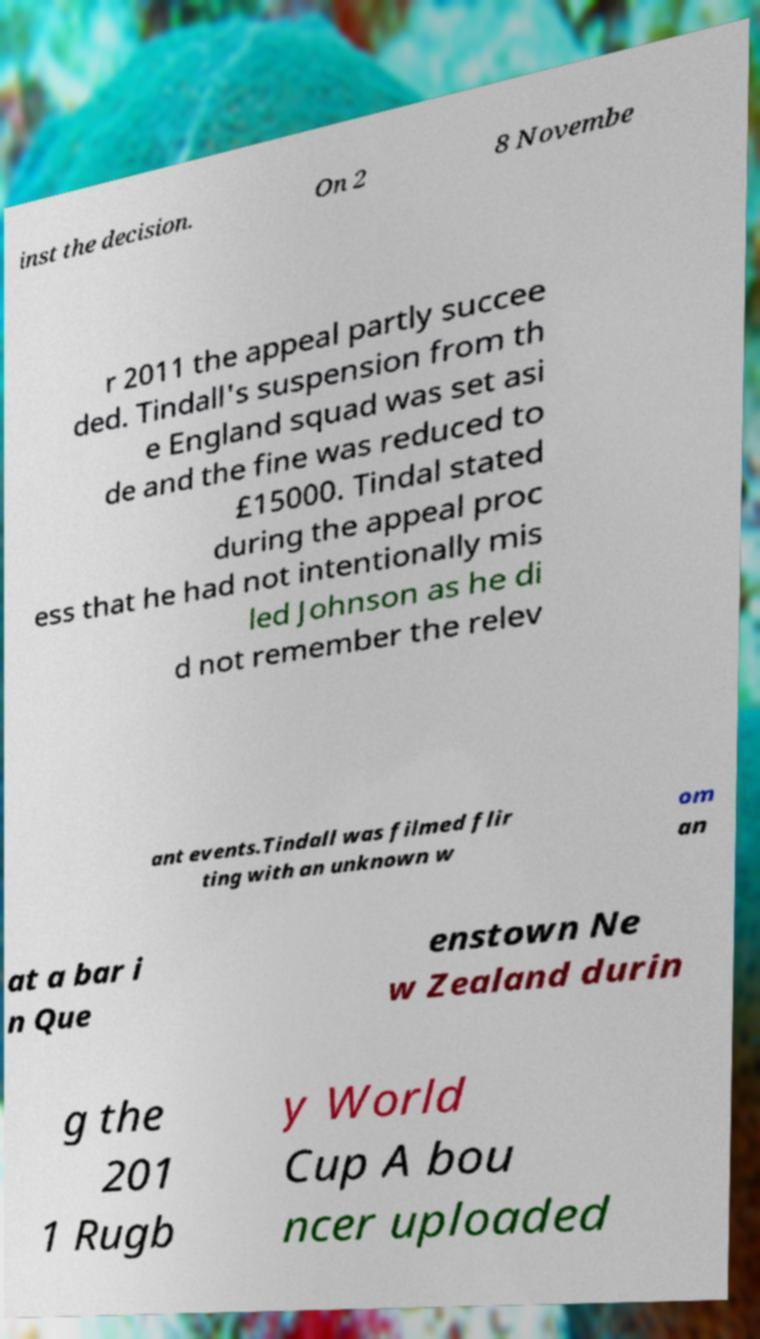I need the written content from this picture converted into text. Can you do that? inst the decision. On 2 8 Novembe r 2011 the appeal partly succee ded. Tindall's suspension from th e England squad was set asi de and the fine was reduced to £15000. Tindal stated during the appeal proc ess that he had not intentionally mis led Johnson as he di d not remember the relev ant events.Tindall was filmed flir ting with an unknown w om an at a bar i n Que enstown Ne w Zealand durin g the 201 1 Rugb y World Cup A bou ncer uploaded 